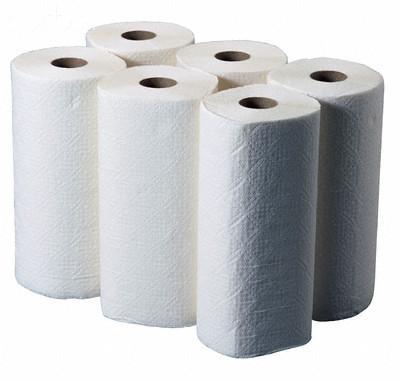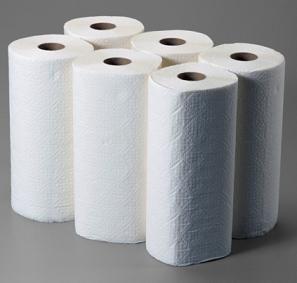The first image is the image on the left, the second image is the image on the right. Given the left and right images, does the statement "There are more than two rolls in each image." hold true? Answer yes or no. Yes. 